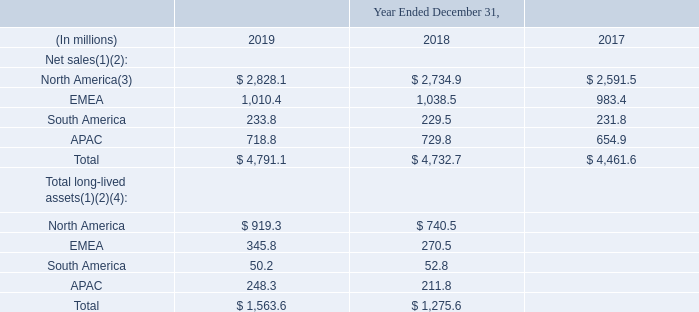Geographic Information
(1) Amounts by geography have been reclassified from prior year disclosure to reflect adjustments to our regional operating model. As of January 1, 2019, our geographic regions are: North America, EMEA, South America and APAC. Our North American operations include Canada, the United States, Mexico and Central America. Mexico and Central America were previously included in Latin America. Refer to Note 2, "Summary of Significant Accounting Policies and Recently Issued Accounting Standards," of the Notes to Consolidated Financial Statements.
(2) No non-U.S. country accounted for net sales in excess of 10% of consolidated net sales for the years ended December 31, 2019, 2018 or 2017 or long-lived assets in excess of 10% of consolidated long-lived assets at December 31, 2019 and 2018.
(3) Net sales to external customers within the U.S. were $2,501.6 million, $2,402.3 million and $2,280.0 million for the years ended December 31, 2019, 2018 and 2017, respectively.
(4) Total long-lived assets represent total assets excluding total current assets, deferred tax assets, goodwill, intangible assets and non-current assets held for sale.
What was the change in geographic classification? Our north american operations include canada, the united states, mexico and central america. mexico and central america were previously included in latin america. What are total long-lived assets? Total long-lived assets represent total assets excluding total current assets, deferred tax assets, goodwill, intangible assets and non-current assets held for sale. What years are included in the table? 2019, 2018, 2017. What was the net sales to customers in North America who are not in the U.S. in 2019?
Answer scale should be: million. 2,828.1-2,501.6
Answer: 326.5. What is the growth rate of total net sales for 2018 to 2019?
Answer scale should be: percent. (4,791.1-4,732.7)/4,732.7
Answer: 1.23. What is of Total long-lived assets for North America expressed as a percentage to all other regions in 2019?
Answer scale should be: percent. 919.3/(1,563.6-919.3)
Answer: 142.68. 